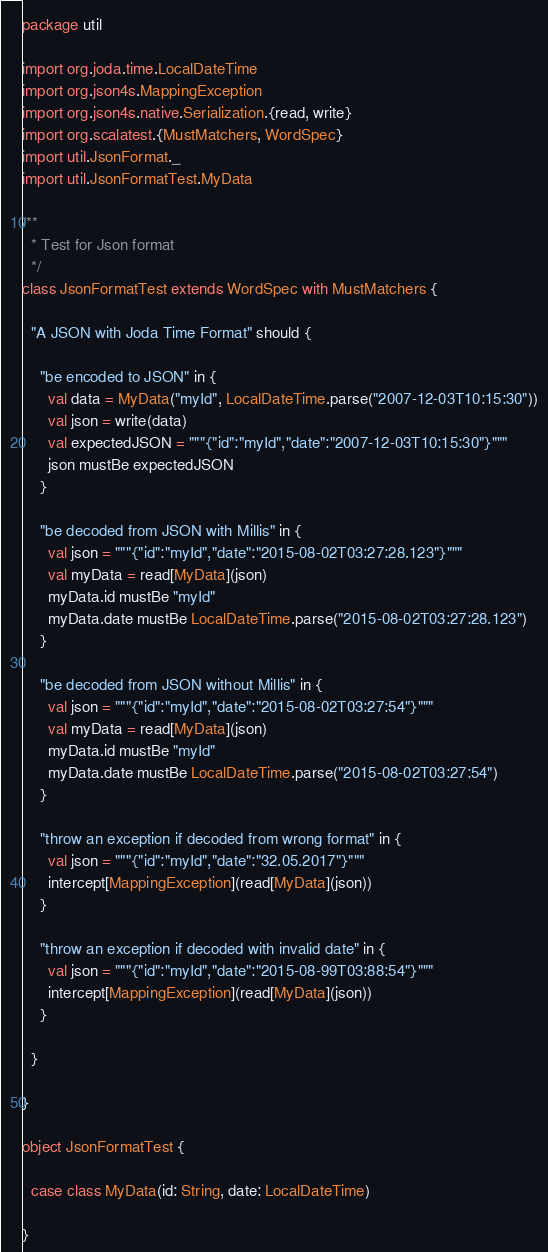<code> <loc_0><loc_0><loc_500><loc_500><_Scala_>package util

import org.joda.time.LocalDateTime
import org.json4s.MappingException
import org.json4s.native.Serialization.{read, write}
import org.scalatest.{MustMatchers, WordSpec}
import util.JsonFormat._
import util.JsonFormatTest.MyData

/**
  * Test for Json format
  */
class JsonFormatTest extends WordSpec with MustMatchers {

  "A JSON with Joda Time Format" should {

    "be encoded to JSON" in {
      val data = MyData("myId", LocalDateTime.parse("2007-12-03T10:15:30"))
      val json = write(data)
      val expectedJSON = """{"id":"myId","date":"2007-12-03T10:15:30"}"""
      json mustBe expectedJSON
    }

    "be decoded from JSON with Millis" in {
      val json = """{"id":"myId","date":"2015-08-02T03:27:28.123"}"""
      val myData = read[MyData](json)
      myData.id mustBe "myId"
      myData.date mustBe LocalDateTime.parse("2015-08-02T03:27:28.123")
    }

    "be decoded from JSON without Millis" in {
      val json = """{"id":"myId","date":"2015-08-02T03:27:54"}"""
      val myData = read[MyData](json)
      myData.id mustBe "myId"
      myData.date mustBe LocalDateTime.parse("2015-08-02T03:27:54")
    }

    "throw an exception if decoded from wrong format" in {
      val json = """{"id":"myId","date":"32.05.2017"}"""
      intercept[MappingException](read[MyData](json))
    }

    "throw an exception if decoded with invalid date" in {
      val json = """{"id":"myId","date":"2015-08-99T03:88:54"}"""
      intercept[MappingException](read[MyData](json))
    }

  }

}

object JsonFormatTest {

  case class MyData(id: String, date: LocalDateTime)

}
</code> 